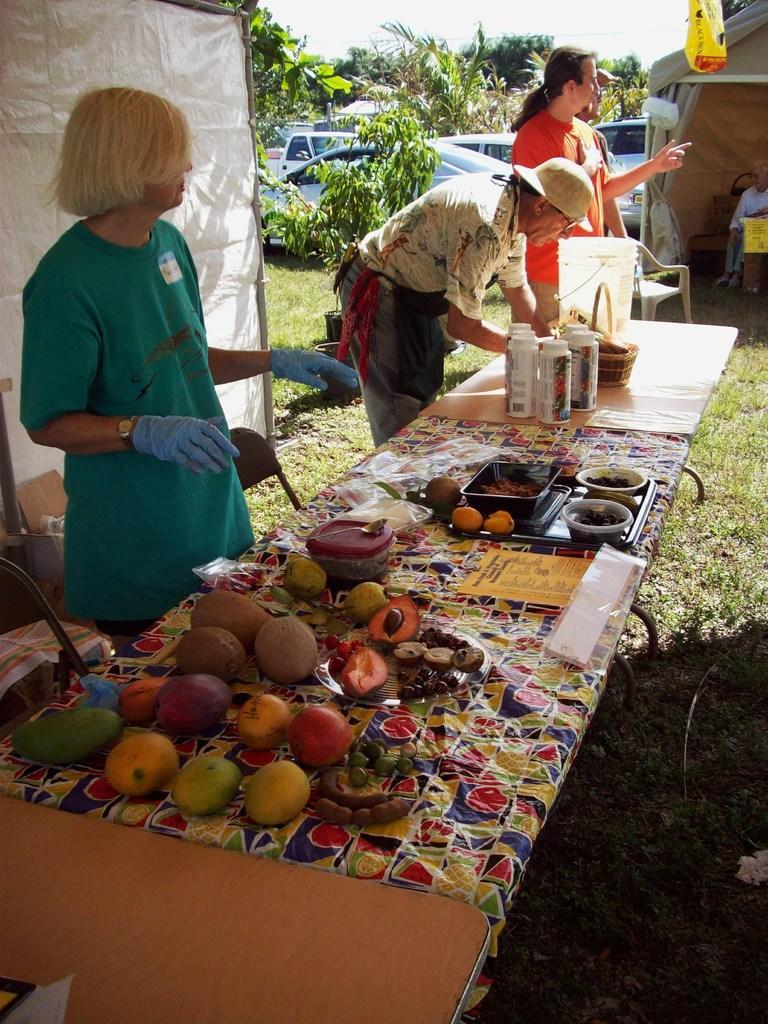How would you summarize this image in a sentence or two? In this image, we can see three persons in front of the table. This table contains a bucket, bottles, bowls and some fruits. There are cars and plants at the top of the image. There is a tent in the top right of the image. 